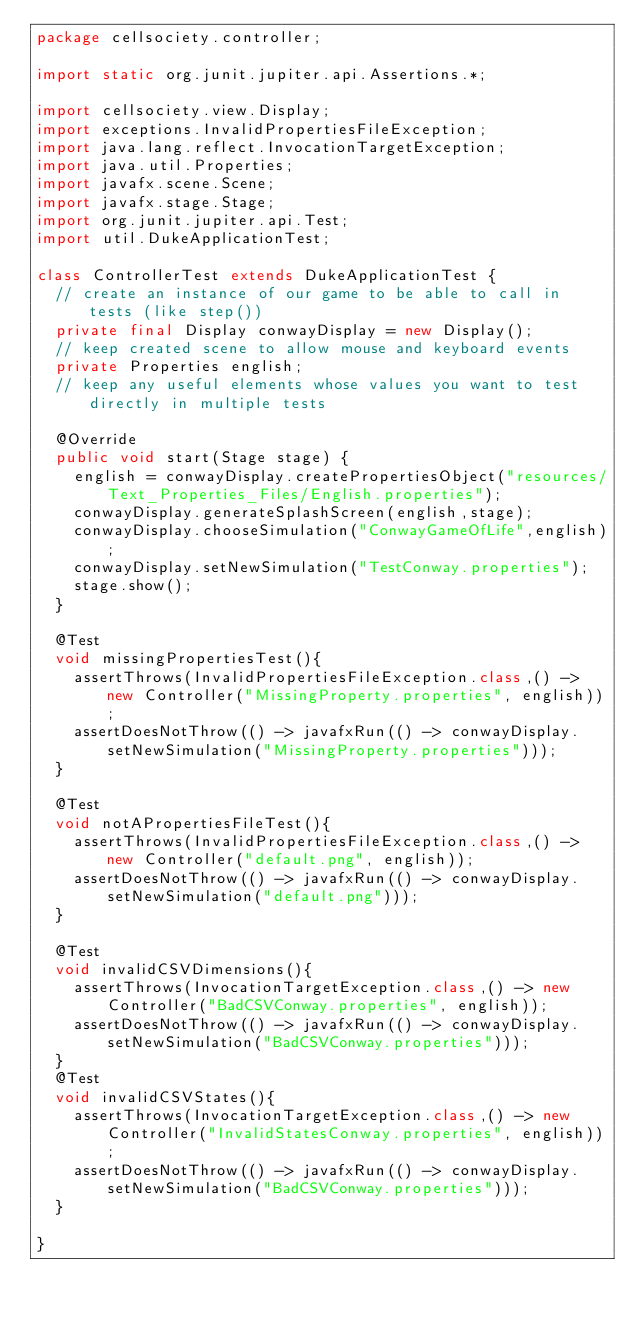<code> <loc_0><loc_0><loc_500><loc_500><_Java_>package cellsociety.controller;

import static org.junit.jupiter.api.Assertions.*;

import cellsociety.view.Display;
import exceptions.InvalidPropertiesFileException;
import java.lang.reflect.InvocationTargetException;
import java.util.Properties;
import javafx.scene.Scene;
import javafx.stage.Stage;
import org.junit.jupiter.api.Test;
import util.DukeApplicationTest;

class ControllerTest extends DukeApplicationTest {
  // create an instance of our game to be able to call in tests (like step())
  private final Display conwayDisplay = new Display();
  // keep created scene to allow mouse and keyboard events
  private Properties english;
  // keep any useful elements whose values you want to test directly in multiple tests

  @Override
  public void start(Stage stage) {
    english = conwayDisplay.createPropertiesObject("resources/Text_Properties_Files/English.properties");
    conwayDisplay.generateSplashScreen(english,stage);
    conwayDisplay.chooseSimulation("ConwayGameOfLife",english);
    conwayDisplay.setNewSimulation("TestConway.properties");
    stage.show();
  }

  @Test
  void missingPropertiesTest(){
    assertThrows(InvalidPropertiesFileException.class,() -> new Controller("MissingProperty.properties", english));
    assertDoesNotThrow(() -> javafxRun(() -> conwayDisplay.setNewSimulation("MissingProperty.properties")));
  }

  @Test
  void notAPropertiesFileTest(){
    assertThrows(InvalidPropertiesFileException.class,() -> new Controller("default.png", english));
    assertDoesNotThrow(() -> javafxRun(() -> conwayDisplay.setNewSimulation("default.png")));
  }

  @Test
  void invalidCSVDimensions(){
    assertThrows(InvocationTargetException.class,() -> new Controller("BadCSVConway.properties", english));
    assertDoesNotThrow(() -> javafxRun(() -> conwayDisplay.setNewSimulation("BadCSVConway.properties")));
  }
  @Test
  void invalidCSVStates(){
    assertThrows(InvocationTargetException.class,() -> new Controller("InvalidStatesConway.properties", english));
    assertDoesNotThrow(() -> javafxRun(() -> conwayDisplay.setNewSimulation("BadCSVConway.properties")));
  }

}</code> 